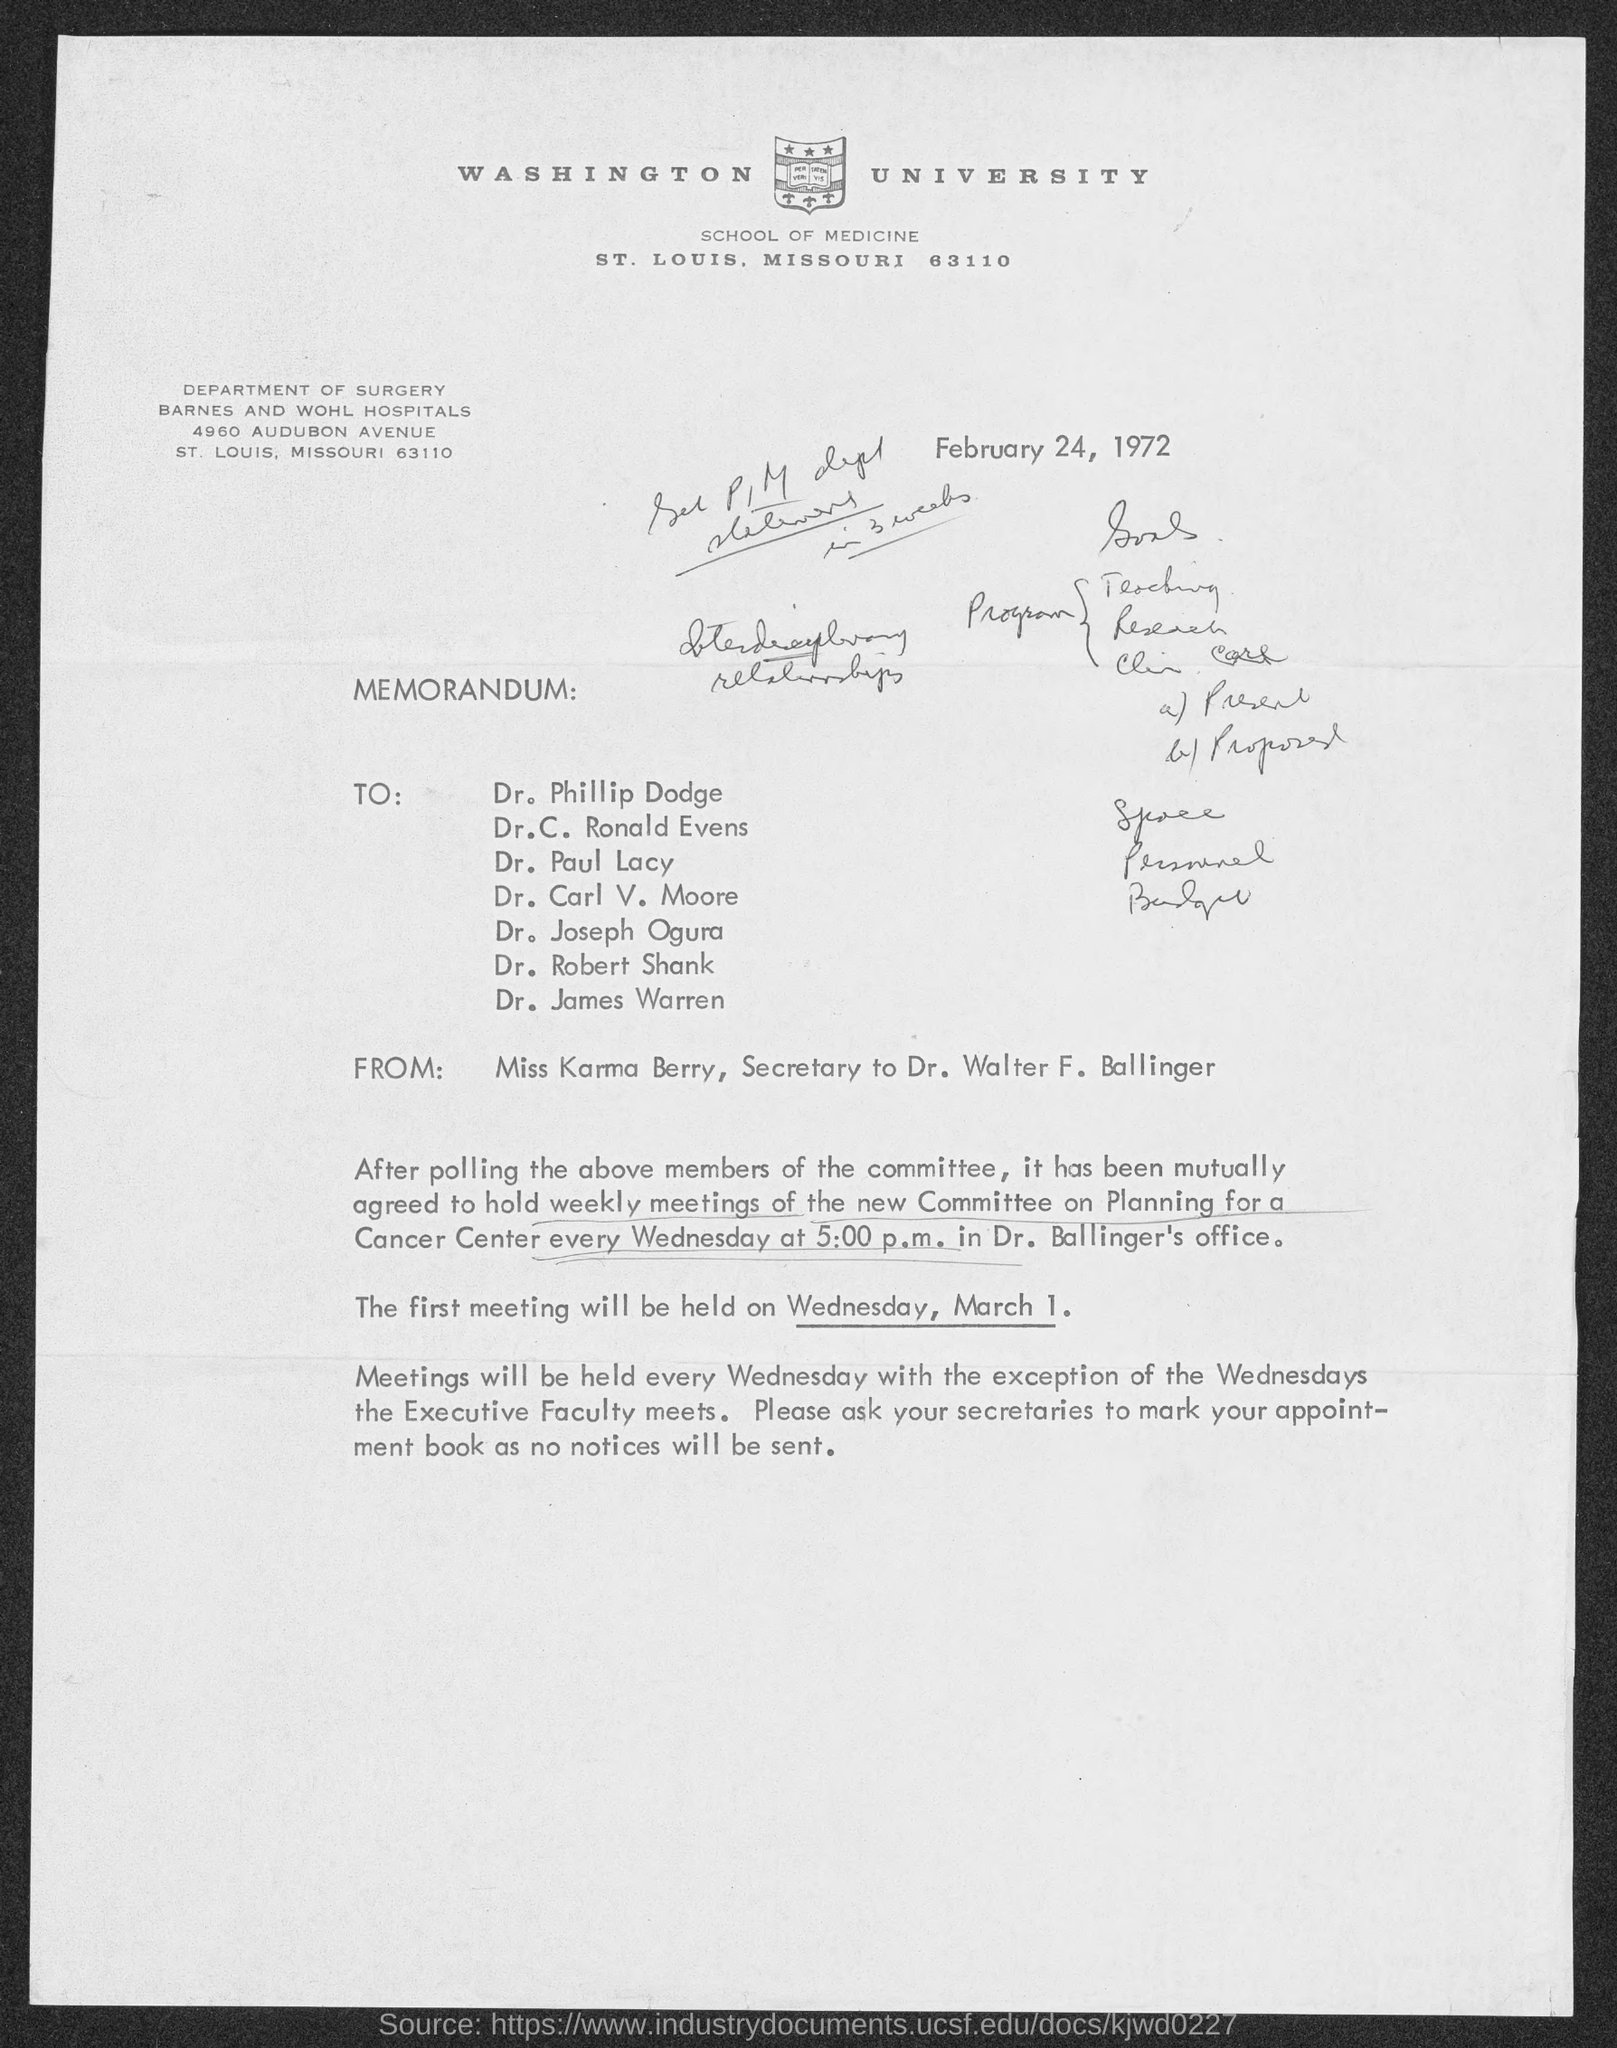Point out several critical features in this image. The street address of Barnes and Wohl Hospitals is 4960 Audubon Avenue. The memorandum was dated February 24, 1972. 